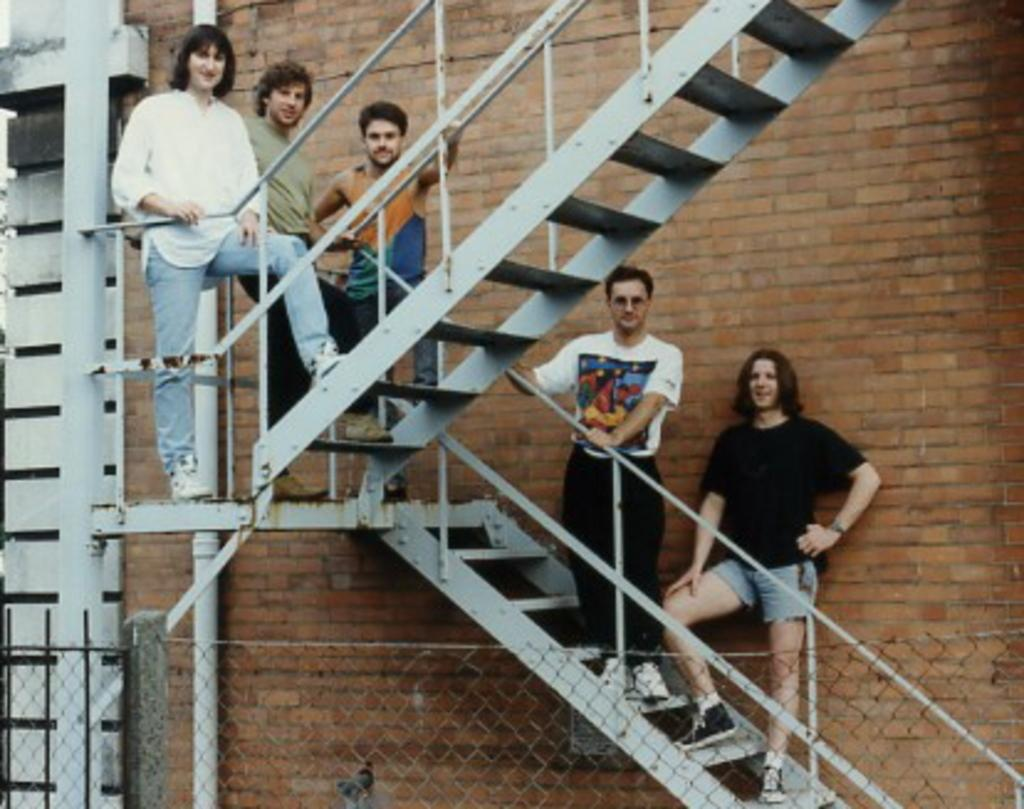What are the people in the image doing? The people in the image are standing on the staircases. What can be seen on the left side of the image? There is a pipe, a railing, and a wall on the left side of the image. What is visible in the background of the image? There is a brick wall in the background of the image. What is present in the foreground of the image? There is fencing in the foreground of the image. What type of sound can be heard coming from the van in the image? There is no van present in the image, so it is not possible to determine what, if any, sound might be heard. 